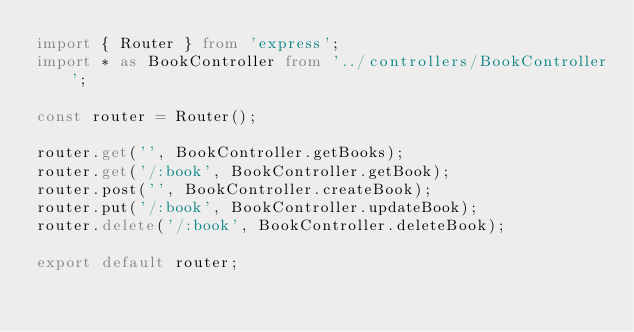<code> <loc_0><loc_0><loc_500><loc_500><_TypeScript_>import { Router } from 'express';
import * as BookController from '../controllers/BookController';

const router = Router();

router.get('', BookController.getBooks);
router.get('/:book', BookController.getBook);
router.post('', BookController.createBook);
router.put('/:book', BookController.updateBook);
router.delete('/:book', BookController.deleteBook);

export default router;
</code> 